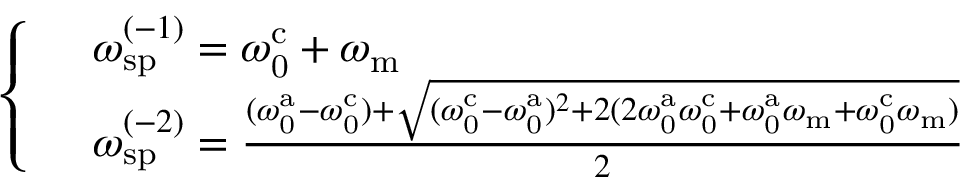<formula> <loc_0><loc_0><loc_500><loc_500>\begin{array} { r l } & { \left \{ \begin{array} { l l } & { \omega _ { s p } ^ { ( - 1 ) } = \omega _ { 0 } ^ { c } + \omega _ { m } } \\ & { \omega _ { s p } ^ { ( - 2 ) } = \frac { ( \omega _ { 0 } ^ { a } - \omega _ { 0 } ^ { c } ) + \sqrt { ( \omega _ { 0 } ^ { c } - \omega _ { 0 } ^ { a } ) ^ { 2 } + 2 ( 2 \omega _ { 0 } ^ { a } \omega _ { 0 } ^ { c } + \omega _ { 0 } ^ { a } \omega _ { m } + \omega _ { 0 } ^ { c } \omega _ { m } ) } } { 2 } } \end{array} } \end{array}</formula> 